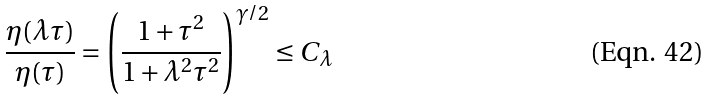<formula> <loc_0><loc_0><loc_500><loc_500>\frac { \eta ( \lambda \tau ) } { \eta ( \tau ) } = \left ( \frac { 1 + \tau ^ { 2 } } { 1 + \lambda ^ { 2 } \tau ^ { 2 } } \right ) ^ { \gamma / 2 } \leq C _ { \lambda }</formula> 